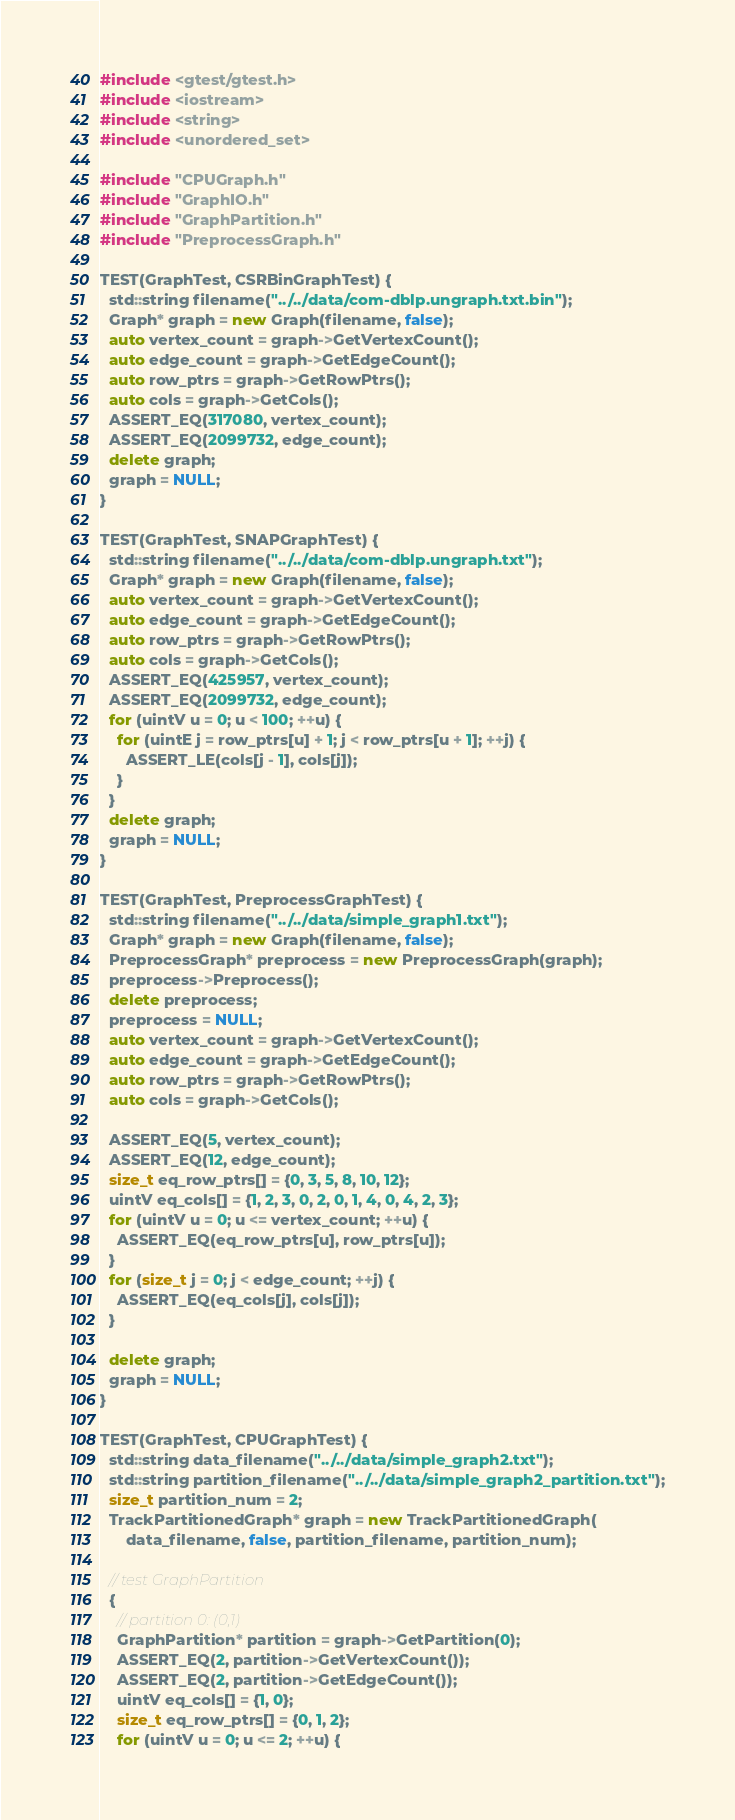<code> <loc_0><loc_0><loc_500><loc_500><_C++_>#include <gtest/gtest.h>
#include <iostream>
#include <string>
#include <unordered_set>

#include "CPUGraph.h"
#include "GraphIO.h"
#include "GraphPartition.h"
#include "PreprocessGraph.h"

TEST(GraphTest, CSRBinGraphTest) {
  std::string filename("../../data/com-dblp.ungraph.txt.bin");
  Graph* graph = new Graph(filename, false);
  auto vertex_count = graph->GetVertexCount();
  auto edge_count = graph->GetEdgeCount();
  auto row_ptrs = graph->GetRowPtrs();
  auto cols = graph->GetCols();
  ASSERT_EQ(317080, vertex_count);
  ASSERT_EQ(2099732, edge_count);
  delete graph;
  graph = NULL;
}

TEST(GraphTest, SNAPGraphTest) {
  std::string filename("../../data/com-dblp.ungraph.txt");
  Graph* graph = new Graph(filename, false);
  auto vertex_count = graph->GetVertexCount();
  auto edge_count = graph->GetEdgeCount();
  auto row_ptrs = graph->GetRowPtrs();
  auto cols = graph->GetCols();
  ASSERT_EQ(425957, vertex_count);
  ASSERT_EQ(2099732, edge_count);
  for (uintV u = 0; u < 100; ++u) {
    for (uintE j = row_ptrs[u] + 1; j < row_ptrs[u + 1]; ++j) {
      ASSERT_LE(cols[j - 1], cols[j]);
    }
  }
  delete graph;
  graph = NULL;
}

TEST(GraphTest, PreprocessGraphTest) {
  std::string filename("../../data/simple_graph1.txt");
  Graph* graph = new Graph(filename, false);
  PreprocessGraph* preprocess = new PreprocessGraph(graph);
  preprocess->Preprocess();
  delete preprocess;
  preprocess = NULL;
  auto vertex_count = graph->GetVertexCount();
  auto edge_count = graph->GetEdgeCount();
  auto row_ptrs = graph->GetRowPtrs();
  auto cols = graph->GetCols();

  ASSERT_EQ(5, vertex_count);
  ASSERT_EQ(12, edge_count);
  size_t eq_row_ptrs[] = {0, 3, 5, 8, 10, 12};
  uintV eq_cols[] = {1, 2, 3, 0, 2, 0, 1, 4, 0, 4, 2, 3};
  for (uintV u = 0; u <= vertex_count; ++u) {
    ASSERT_EQ(eq_row_ptrs[u], row_ptrs[u]);
  }
  for (size_t j = 0; j < edge_count; ++j) {
    ASSERT_EQ(eq_cols[j], cols[j]);
  }

  delete graph;
  graph = NULL;
}

TEST(GraphTest, CPUGraphTest) {
  std::string data_filename("../../data/simple_graph2.txt");
  std::string partition_filename("../../data/simple_graph2_partition.txt");
  size_t partition_num = 2;
  TrackPartitionedGraph* graph = new TrackPartitionedGraph(
      data_filename, false, partition_filename, partition_num);

  // test GraphPartition
  {
    // partition 0: (0,1)
    GraphPartition* partition = graph->GetPartition(0);
    ASSERT_EQ(2, partition->GetVertexCount());
    ASSERT_EQ(2, partition->GetEdgeCount());
    uintV eq_cols[] = {1, 0};
    size_t eq_row_ptrs[] = {0, 1, 2};
    for (uintV u = 0; u <= 2; ++u) {</code> 